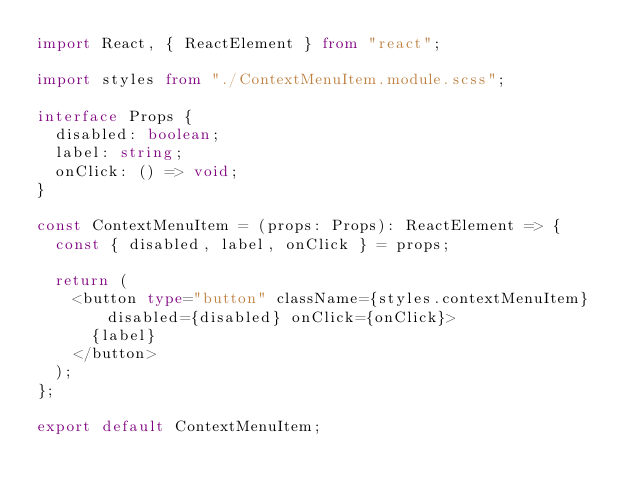Convert code to text. <code><loc_0><loc_0><loc_500><loc_500><_TypeScript_>import React, { ReactElement } from "react";

import styles from "./ContextMenuItem.module.scss";

interface Props {
	disabled: boolean;
	label: string;
	onClick: () => void;
}

const ContextMenuItem = (props: Props): ReactElement => {
	const { disabled, label, onClick } = props;

	return (
		<button type="button" className={styles.contextMenuItem} disabled={disabled} onClick={onClick}>
			{label}
		</button>
	);
};

export default ContextMenuItem;
</code> 